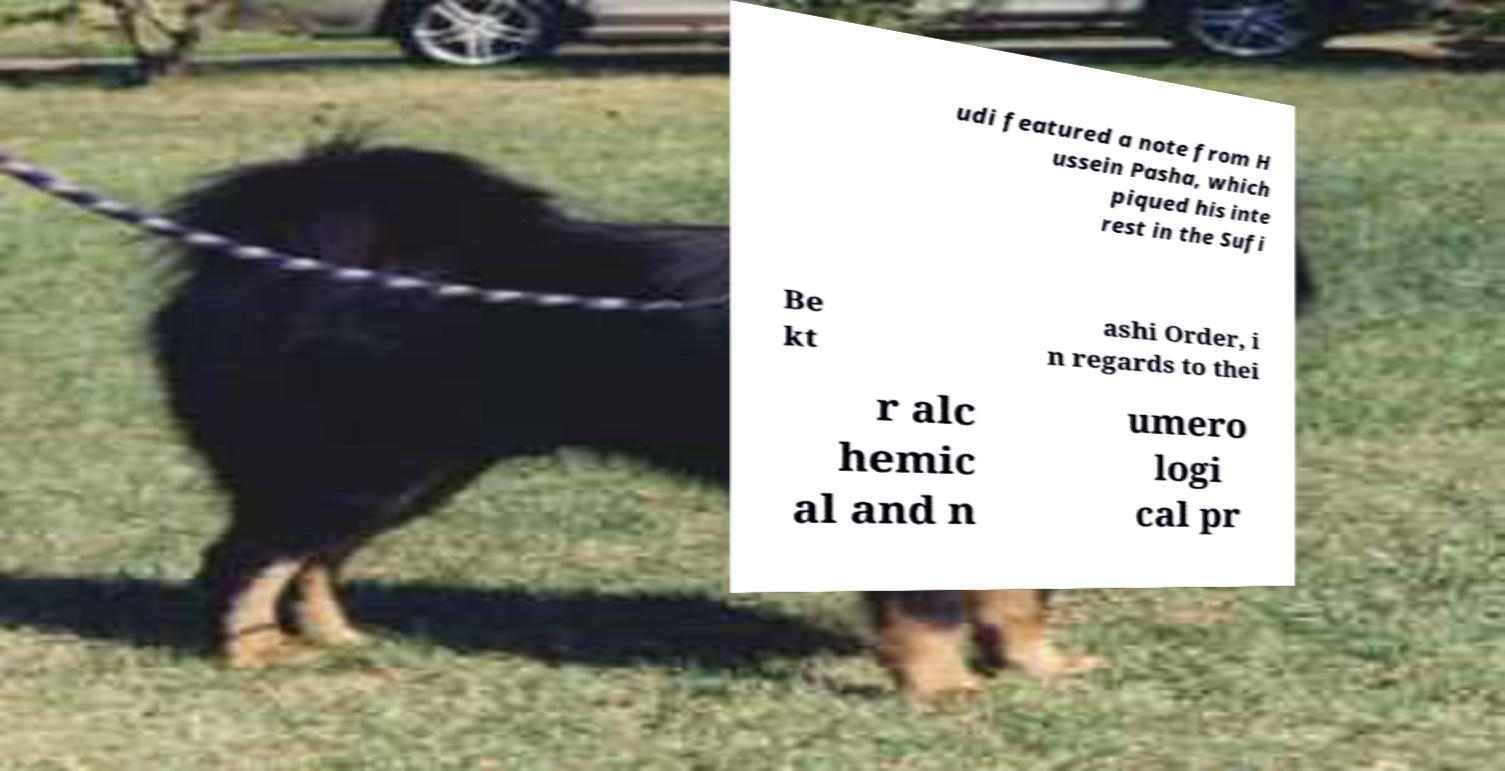Could you extract and type out the text from this image? udi featured a note from H ussein Pasha, which piqued his inte rest in the Sufi Be kt ashi Order, i n regards to thei r alc hemic al and n umero logi cal pr 